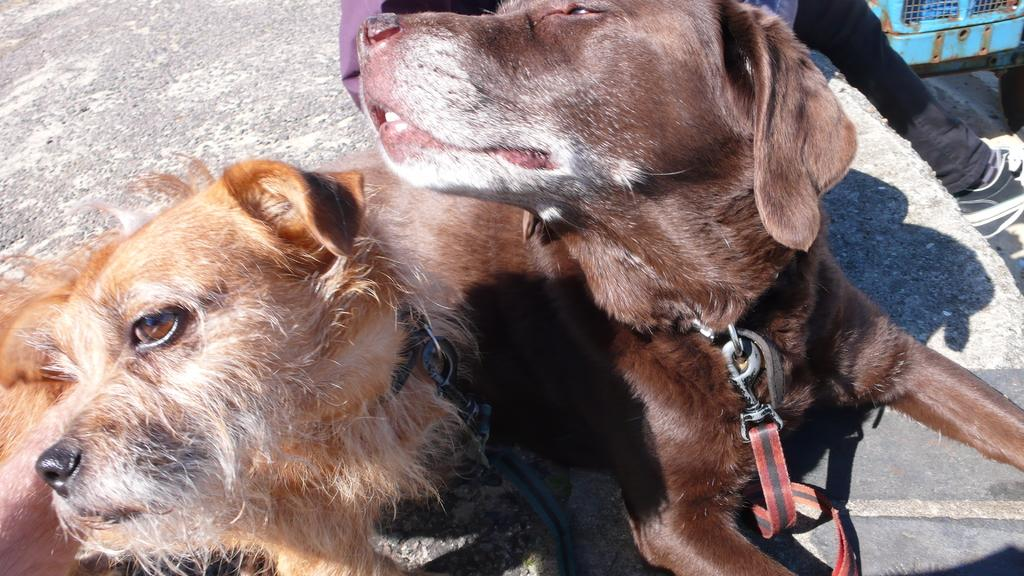How many dogs are in the image? There are two dogs in the image. What are the dogs wearing around their necks? The dogs are wearing neck belts. Can you see any part of a person in the image? Yes, a person's leg is visible in the image. What type of footwear is the person wearing? The person is wearing a shoe. What type of corn is being stored in the sack in the image? There is no corn or sack present in the image. 